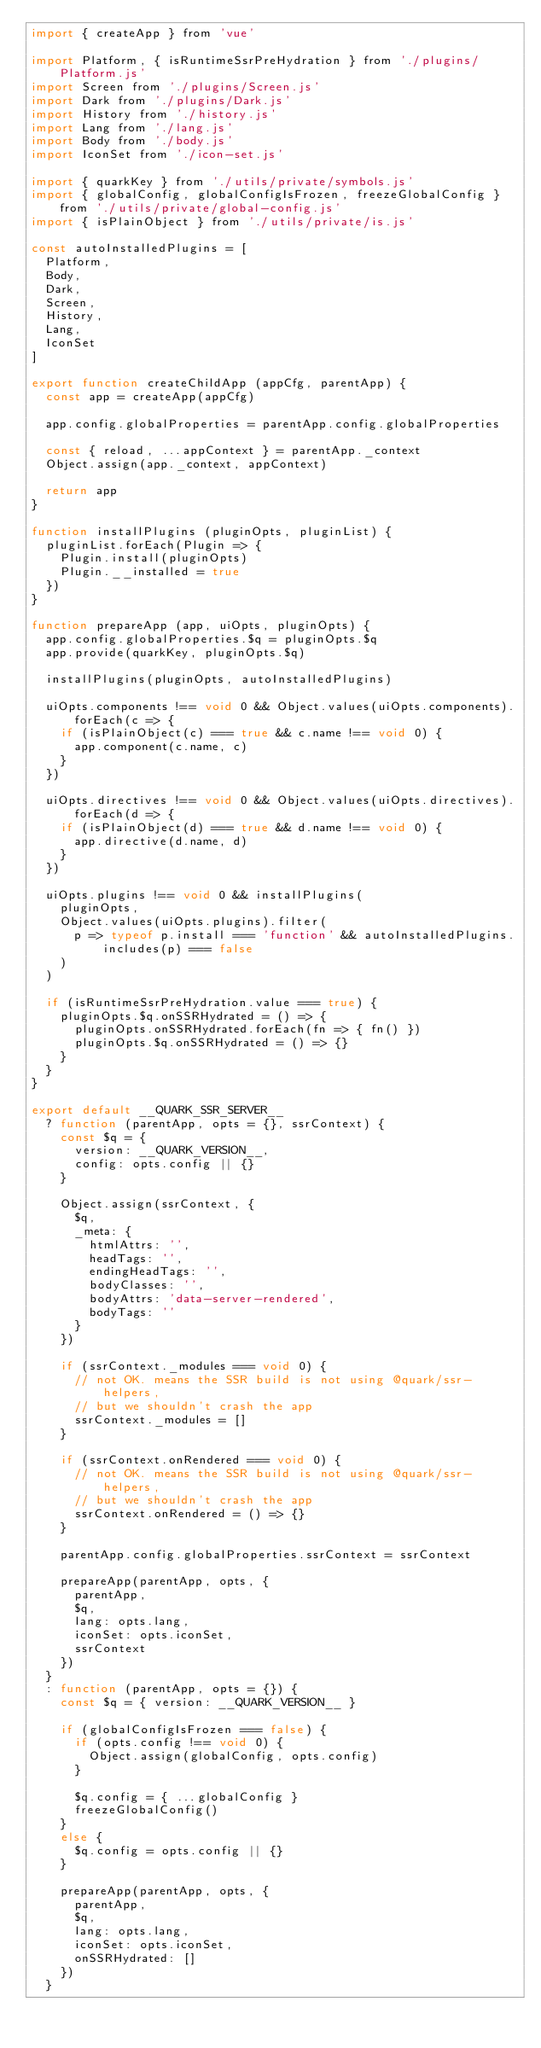Convert code to text. <code><loc_0><loc_0><loc_500><loc_500><_JavaScript_>import { createApp } from 'vue'

import Platform, { isRuntimeSsrPreHydration } from './plugins/Platform.js'
import Screen from './plugins/Screen.js'
import Dark from './plugins/Dark.js'
import History from './history.js'
import Lang from './lang.js'
import Body from './body.js'
import IconSet from './icon-set.js'

import { quarkKey } from './utils/private/symbols.js'
import { globalConfig, globalConfigIsFrozen, freezeGlobalConfig } from './utils/private/global-config.js'
import { isPlainObject } from './utils/private/is.js'

const autoInstalledPlugins = [
  Platform,
  Body,
  Dark,
  Screen,
  History,
  Lang,
  IconSet
]

export function createChildApp (appCfg, parentApp) {
  const app = createApp(appCfg)

  app.config.globalProperties = parentApp.config.globalProperties

  const { reload, ...appContext } = parentApp._context
  Object.assign(app._context, appContext)

  return app
}

function installPlugins (pluginOpts, pluginList) {
  pluginList.forEach(Plugin => {
    Plugin.install(pluginOpts)
    Plugin.__installed = true
  })
}

function prepareApp (app, uiOpts, pluginOpts) {
  app.config.globalProperties.$q = pluginOpts.$q
  app.provide(quarkKey, pluginOpts.$q)

  installPlugins(pluginOpts, autoInstalledPlugins)

  uiOpts.components !== void 0 && Object.values(uiOpts.components).forEach(c => {
    if (isPlainObject(c) === true && c.name !== void 0) {
      app.component(c.name, c)
    }
  })

  uiOpts.directives !== void 0 && Object.values(uiOpts.directives).forEach(d => {
    if (isPlainObject(d) === true && d.name !== void 0) {
      app.directive(d.name, d)
    }
  })

  uiOpts.plugins !== void 0 && installPlugins(
    pluginOpts,
    Object.values(uiOpts.plugins).filter(
      p => typeof p.install === 'function' && autoInstalledPlugins.includes(p) === false
    )
  )

  if (isRuntimeSsrPreHydration.value === true) {
    pluginOpts.$q.onSSRHydrated = () => {
      pluginOpts.onSSRHydrated.forEach(fn => { fn() })
      pluginOpts.$q.onSSRHydrated = () => {}
    }
  }
}

export default __QUARK_SSR_SERVER__
  ? function (parentApp, opts = {}, ssrContext) {
    const $q = {
      version: __QUARK_VERSION__,
      config: opts.config || {}
    }

    Object.assign(ssrContext, {
      $q,
      _meta: {
        htmlAttrs: '',
        headTags: '',
        endingHeadTags: '',
        bodyClasses: '',
        bodyAttrs: 'data-server-rendered',
        bodyTags: ''
      }
    })

    if (ssrContext._modules === void 0) {
      // not OK. means the SSR build is not using @quark/ssr-helpers,
      // but we shouldn't crash the app
      ssrContext._modules = []
    }

    if (ssrContext.onRendered === void 0) {
      // not OK. means the SSR build is not using @quark/ssr-helpers,
      // but we shouldn't crash the app
      ssrContext.onRendered = () => {}
    }

    parentApp.config.globalProperties.ssrContext = ssrContext

    prepareApp(parentApp, opts, {
      parentApp,
      $q,
      lang: opts.lang,
      iconSet: opts.iconSet,
      ssrContext
    })
  }
  : function (parentApp, opts = {}) {
    const $q = { version: __QUARK_VERSION__ }

    if (globalConfigIsFrozen === false) {
      if (opts.config !== void 0) {
        Object.assign(globalConfig, opts.config)
      }

      $q.config = { ...globalConfig }
      freezeGlobalConfig()
    }
    else {
      $q.config = opts.config || {}
    }

    prepareApp(parentApp, opts, {
      parentApp,
      $q,
      lang: opts.lang,
      iconSet: opts.iconSet,
      onSSRHydrated: []
    })
  }
</code> 